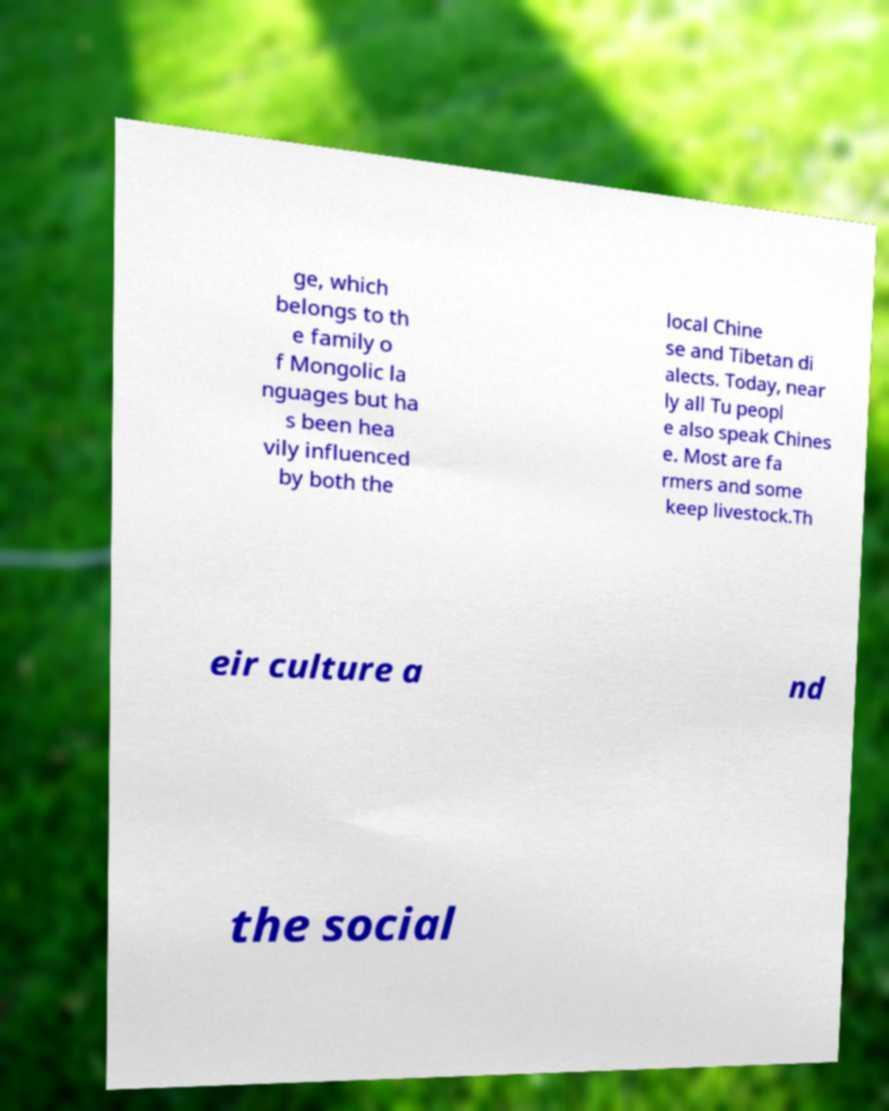I need the written content from this picture converted into text. Can you do that? ge, which belongs to th e family o f Mongolic la nguages but ha s been hea vily influenced by both the local Chine se and Tibetan di alects. Today, near ly all Tu peopl e also speak Chines e. Most are fa rmers and some keep livestock.Th eir culture a nd the social 